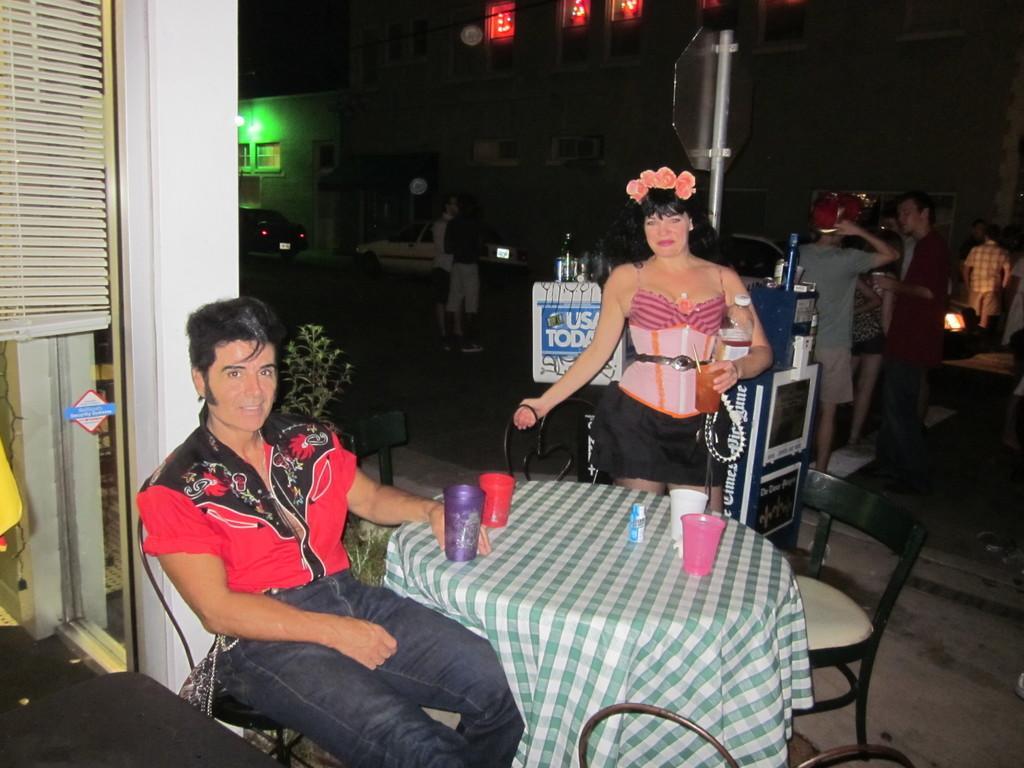Could you give a brief overview of what you see in this image? On this table there are cups. This man is sitting on a chair and holding cup. This woman is standing and holding a cup and bottle. A vehicles on road. These are buildings with lights. These persons are standing. 